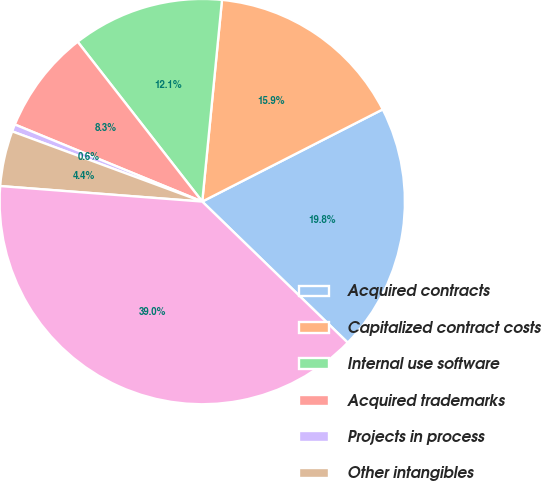<chart> <loc_0><loc_0><loc_500><loc_500><pie_chart><fcel>Acquired contracts<fcel>Capitalized contract costs<fcel>Internal use software<fcel>Acquired trademarks<fcel>Projects in process<fcel>Other intangibles<fcel>Total other intangible assets<nl><fcel>19.77%<fcel>15.93%<fcel>12.09%<fcel>8.25%<fcel>0.58%<fcel>4.41%<fcel>38.96%<nl></chart> 